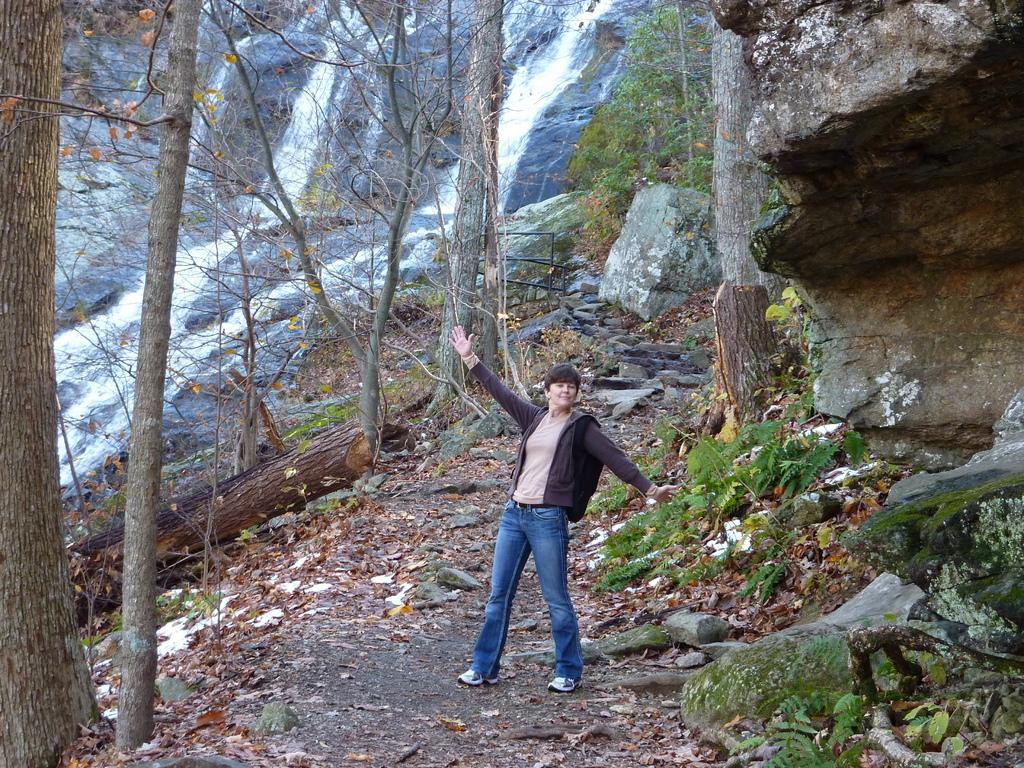Can you describe this image briefly? In this image there is a person standing. Around the person there are rocks, trees and there is a waterfall. 